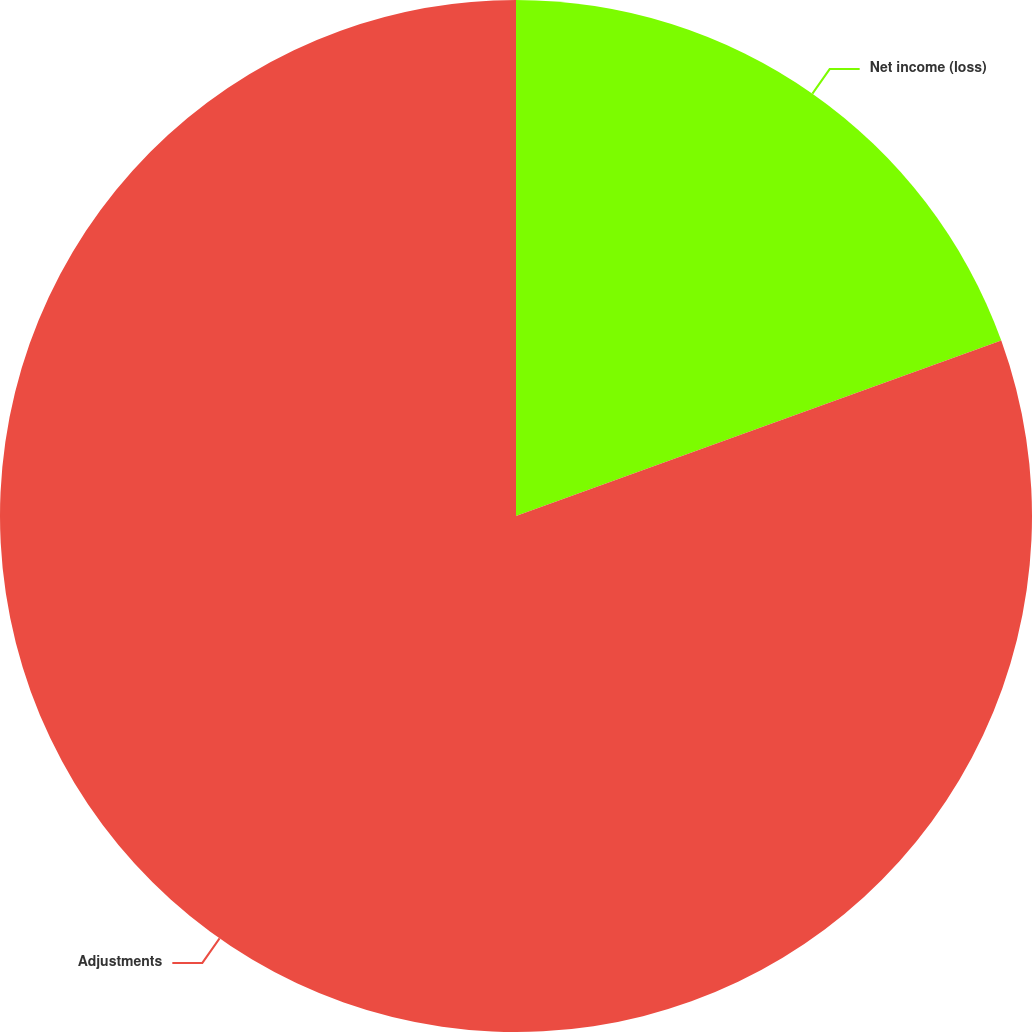Convert chart. <chart><loc_0><loc_0><loc_500><loc_500><pie_chart><fcel>Net income (loss)<fcel>Adjustments<nl><fcel>19.48%<fcel>80.52%<nl></chart> 